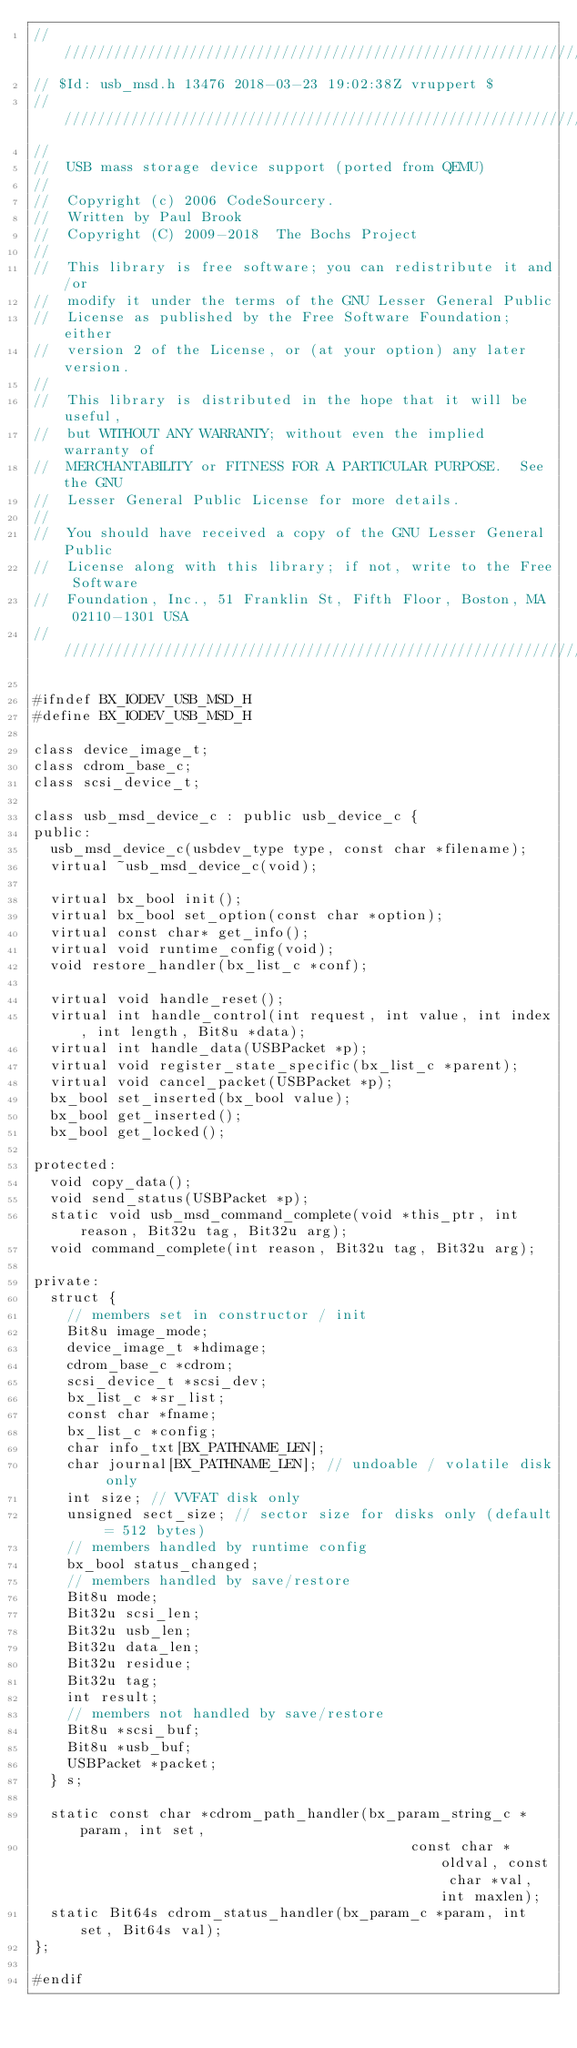Convert code to text. <code><loc_0><loc_0><loc_500><loc_500><_C_>/////////////////////////////////////////////////////////////////////////
// $Id: usb_msd.h 13476 2018-03-23 19:02:38Z vruppert $
/////////////////////////////////////////////////////////////////////////
//
//  USB mass storage device support (ported from QEMU)
//
//  Copyright (c) 2006 CodeSourcery.
//  Written by Paul Brook
//  Copyright (C) 2009-2018  The Bochs Project
//
//  This library is free software; you can redistribute it and/or
//  modify it under the terms of the GNU Lesser General Public
//  License as published by the Free Software Foundation; either
//  version 2 of the License, or (at your option) any later version.
//
//  This library is distributed in the hope that it will be useful,
//  but WITHOUT ANY WARRANTY; without even the implied warranty of
//  MERCHANTABILITY or FITNESS FOR A PARTICULAR PURPOSE.  See the GNU
//  Lesser General Public License for more details.
//
//  You should have received a copy of the GNU Lesser General Public
//  License along with this library; if not, write to the Free Software
//  Foundation, Inc., 51 Franklin St, Fifth Floor, Boston, MA  02110-1301 USA
/////////////////////////////////////////////////////////////////////////

#ifndef BX_IODEV_USB_MSD_H
#define BX_IODEV_USB_MSD_H

class device_image_t;
class cdrom_base_c;
class scsi_device_t;

class usb_msd_device_c : public usb_device_c {
public:
  usb_msd_device_c(usbdev_type type, const char *filename);
  virtual ~usb_msd_device_c(void);

  virtual bx_bool init();
  virtual bx_bool set_option(const char *option);
  virtual const char* get_info();
  virtual void runtime_config(void);
  void restore_handler(bx_list_c *conf);

  virtual void handle_reset();
  virtual int handle_control(int request, int value, int index, int length, Bit8u *data);
  virtual int handle_data(USBPacket *p);
  virtual void register_state_specific(bx_list_c *parent);
  virtual void cancel_packet(USBPacket *p);
  bx_bool set_inserted(bx_bool value);
  bx_bool get_inserted();
  bx_bool get_locked();

protected:
  void copy_data();
  void send_status(USBPacket *p);
  static void usb_msd_command_complete(void *this_ptr, int reason, Bit32u tag, Bit32u arg);
  void command_complete(int reason, Bit32u tag, Bit32u arg);

private:
  struct {
    // members set in constructor / init
    Bit8u image_mode;
    device_image_t *hdimage;
    cdrom_base_c *cdrom;
    scsi_device_t *scsi_dev;
    bx_list_c *sr_list;
    const char *fname;
    bx_list_c *config;
    char info_txt[BX_PATHNAME_LEN];
    char journal[BX_PATHNAME_LEN]; // undoable / volatile disk only
    int size; // VVFAT disk only
    unsigned sect_size; // sector size for disks only (default = 512 bytes)
    // members handled by runtime config
    bx_bool status_changed;
    // members handled by save/restore
    Bit8u mode;
    Bit32u scsi_len;
    Bit32u usb_len;
    Bit32u data_len;
    Bit32u residue;
    Bit32u tag;
    int result;
    // members not handled by save/restore
    Bit8u *scsi_buf;
    Bit8u *usb_buf;
    USBPacket *packet;
  } s;

  static const char *cdrom_path_handler(bx_param_string_c *param, int set,
                                             const char *oldval, const char *val, int maxlen);
  static Bit64s cdrom_status_handler(bx_param_c *param, int set, Bit64s val);
};

#endif
</code> 